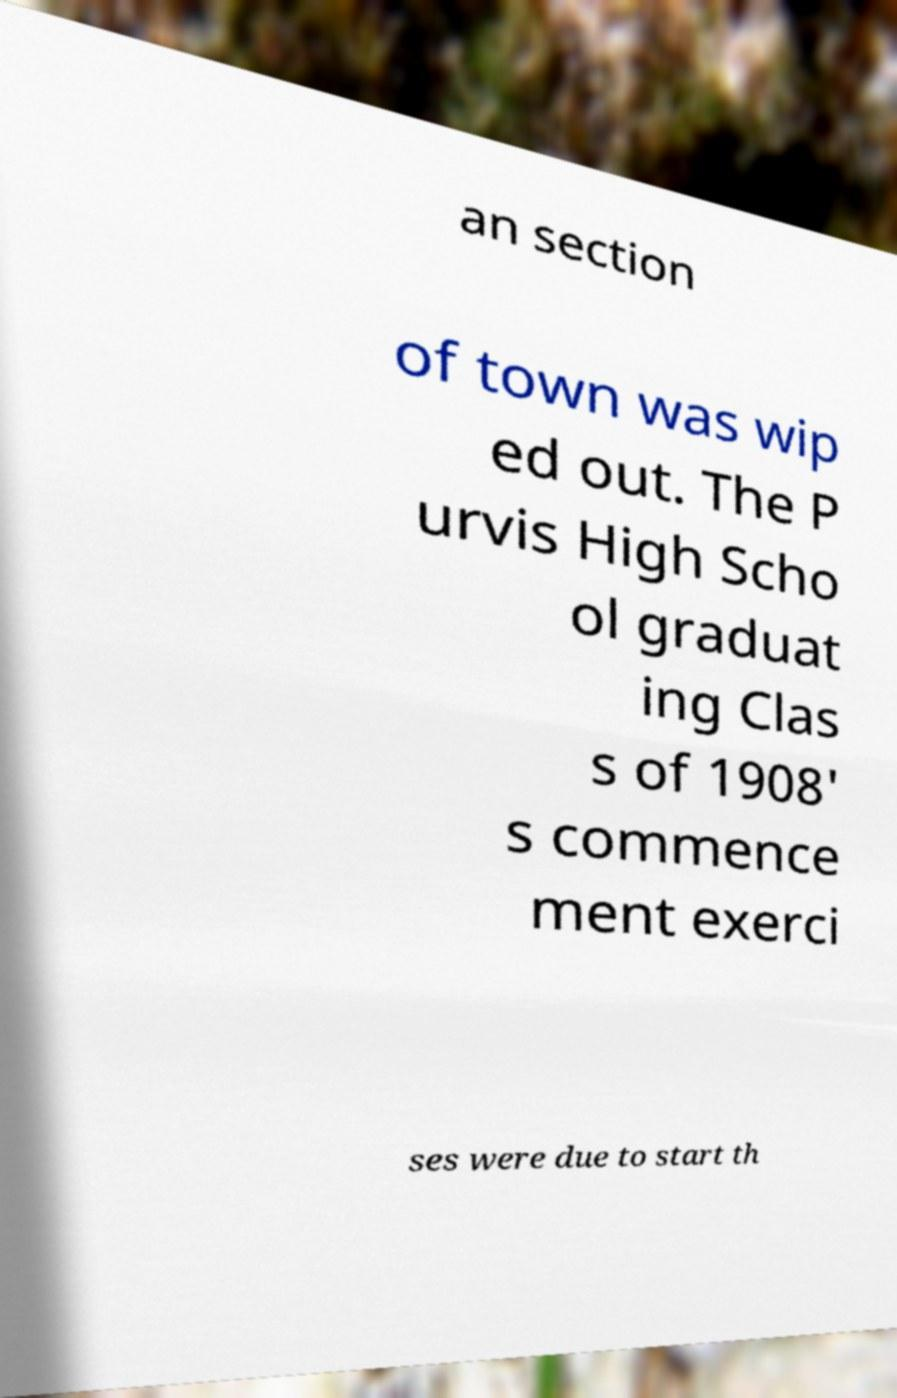Please identify and transcribe the text found in this image. an section of town was wip ed out. The P urvis High Scho ol graduat ing Clas s of 1908' s commence ment exerci ses were due to start th 